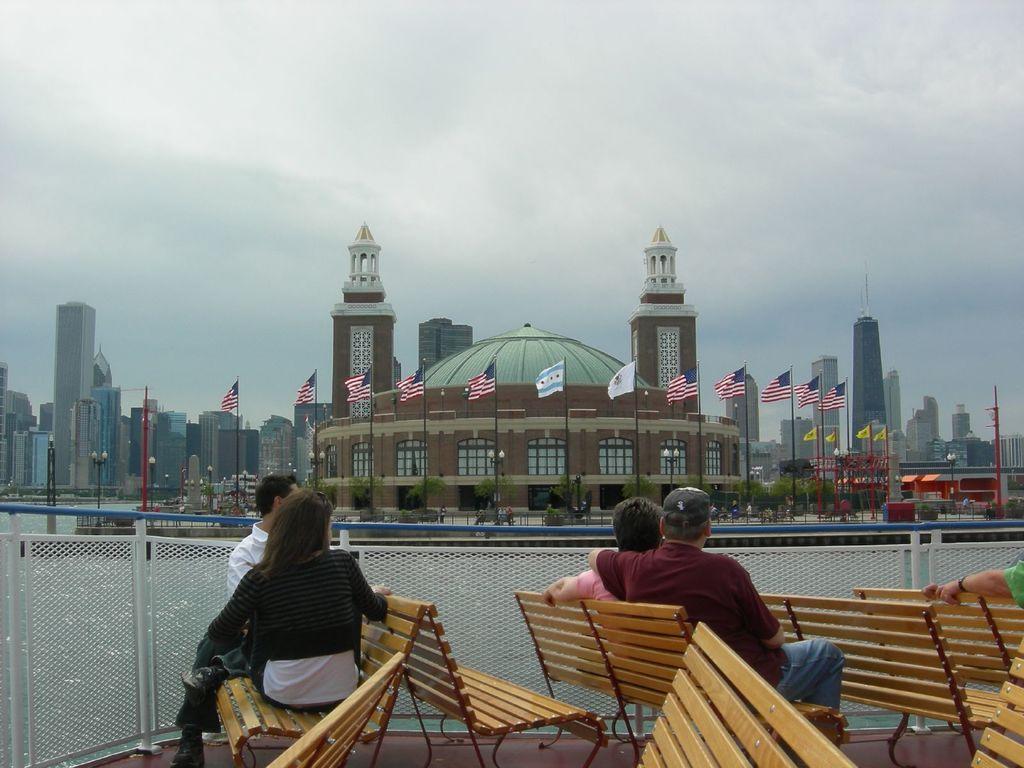In one or two sentences, can you explain what this image depicts? This picture is clicked outside. In the foreground we can see the benches and the group of people sitting on the benches and we can see the net, metal rods, trees, flags, buildings, dome, skyscrapers and many other objects. In the background we can see the sky and in the center we can see the lampposts and the group of people. 